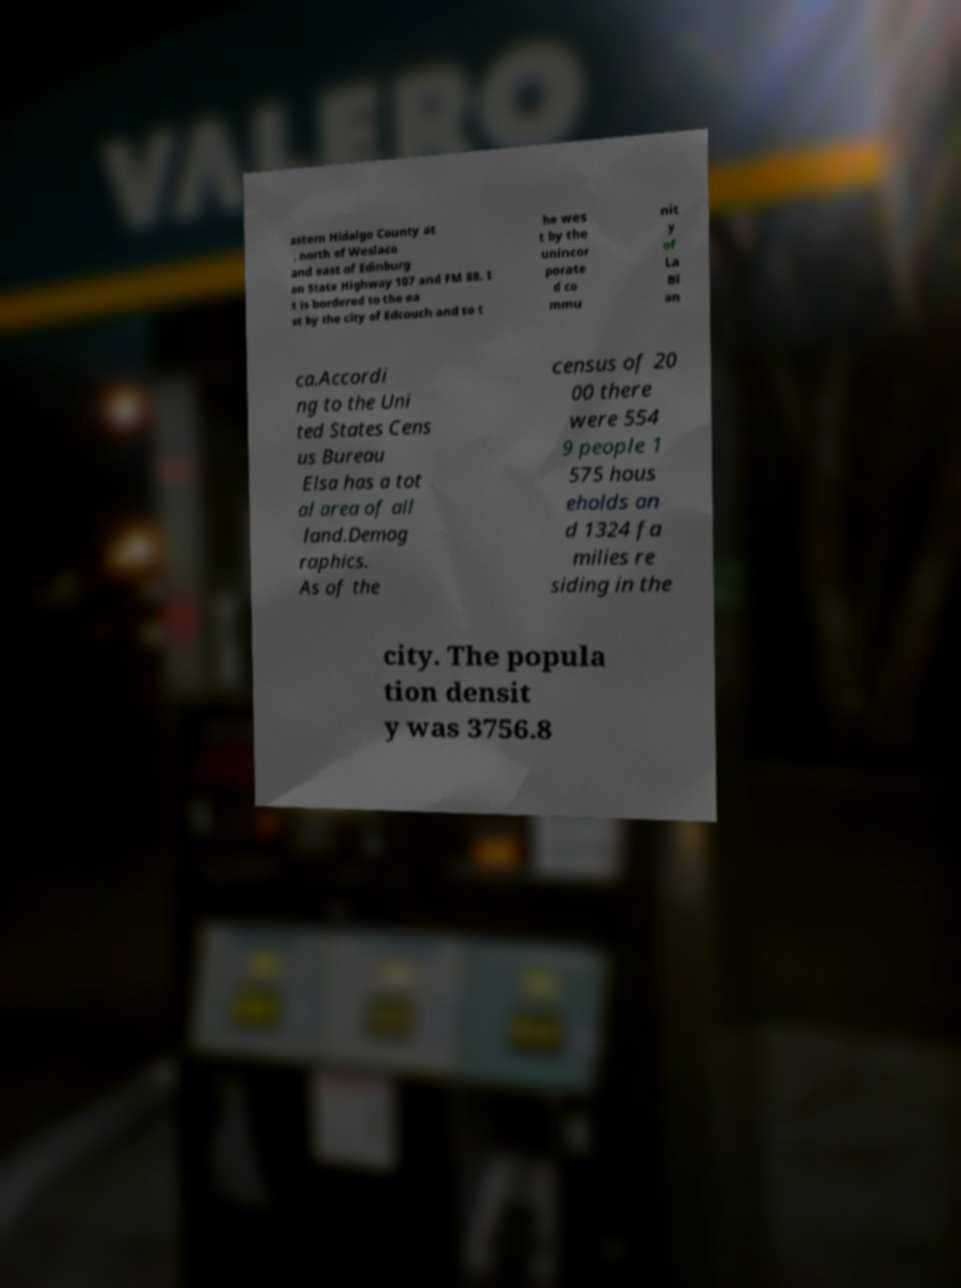Could you extract and type out the text from this image? astern Hidalgo County at , north of Weslaco and east of Edinburg on State Highway 107 and FM 88. I t is bordered to the ea st by the city of Edcouch and to t he wes t by the unincor porate d co mmu nit y of La Bl an ca.Accordi ng to the Uni ted States Cens us Bureau Elsa has a tot al area of all land.Demog raphics. As of the census of 20 00 there were 554 9 people 1 575 hous eholds an d 1324 fa milies re siding in the city. The popula tion densit y was 3756.8 